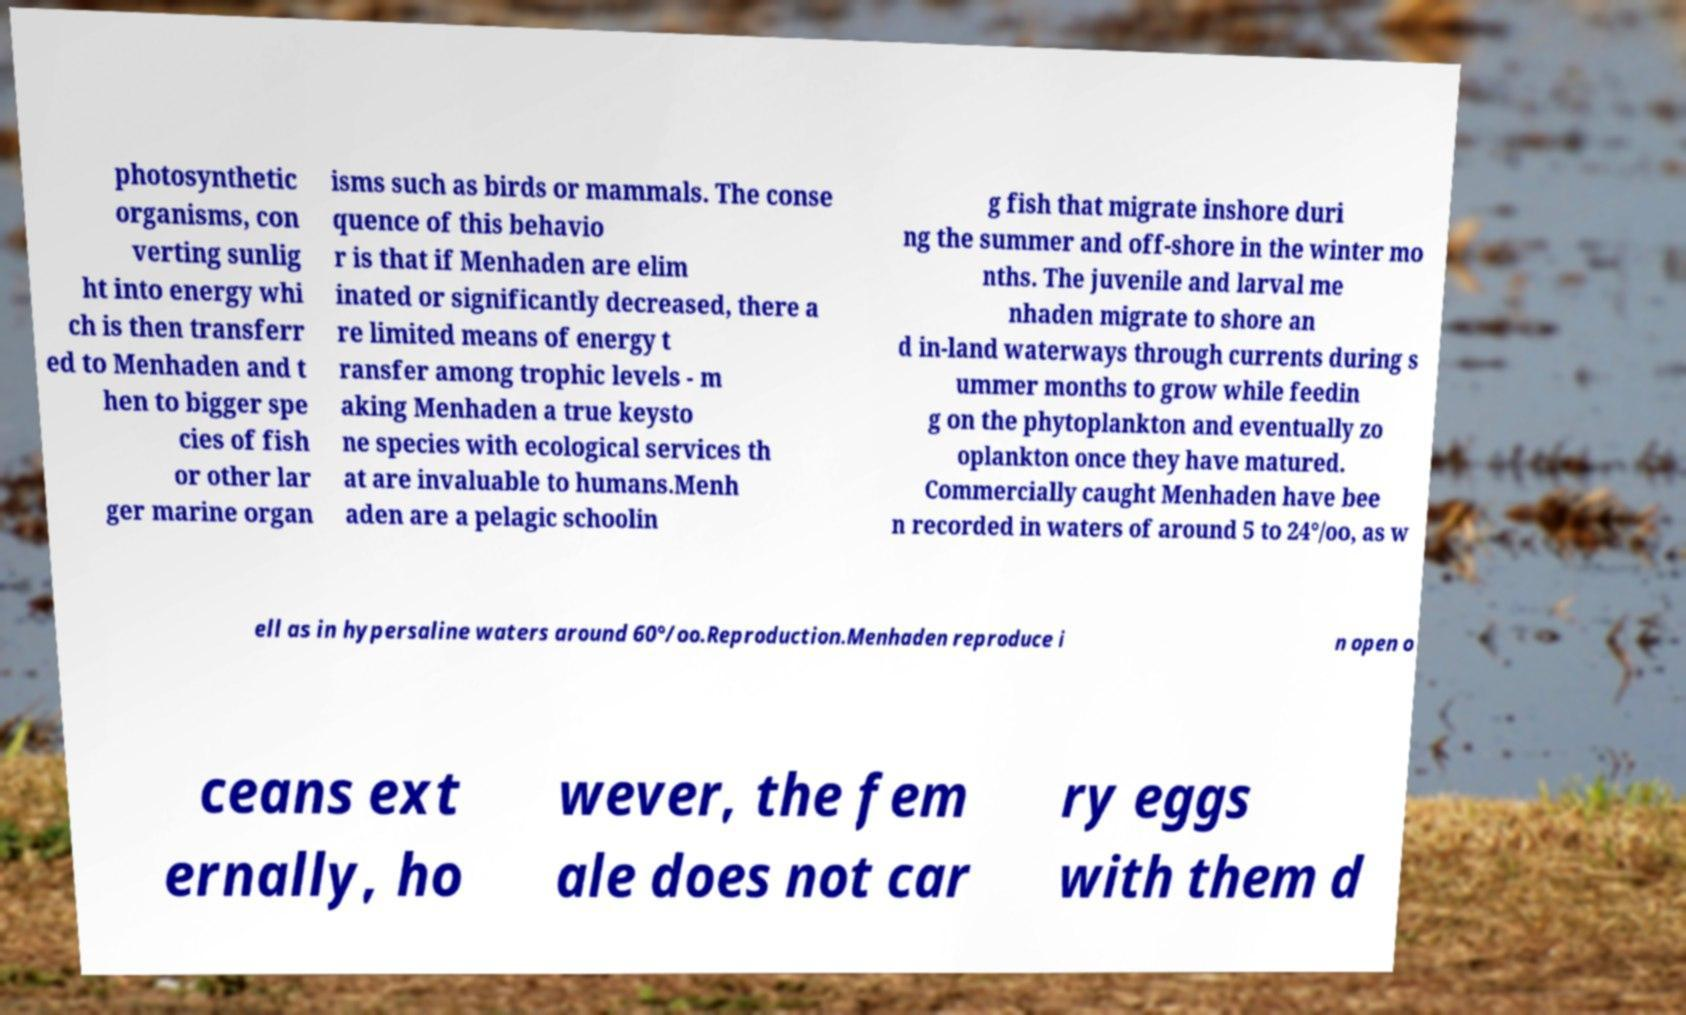Can you read and provide the text displayed in the image?This photo seems to have some interesting text. Can you extract and type it out for me? photosynthetic organisms, con verting sunlig ht into energy whi ch is then transferr ed to Menhaden and t hen to bigger spe cies of fish or other lar ger marine organ isms such as birds or mammals. The conse quence of this behavio r is that if Menhaden are elim inated or significantly decreased, there a re limited means of energy t ransfer among trophic levels - m aking Menhaden a true keysto ne species with ecological services th at are invaluable to humans.Menh aden are a pelagic schoolin g fish that migrate inshore duri ng the summer and off-shore in the winter mo nths. The juvenile and larval me nhaden migrate to shore an d in-land waterways through currents during s ummer months to grow while feedin g on the phytoplankton and eventually zo oplankton once they have matured. Commercially caught Menhaden have bee n recorded in waters of around 5 to 24°/oo, as w ell as in hypersaline waters around 60°/oo.Reproduction.Menhaden reproduce i n open o ceans ext ernally, ho wever, the fem ale does not car ry eggs with them d 